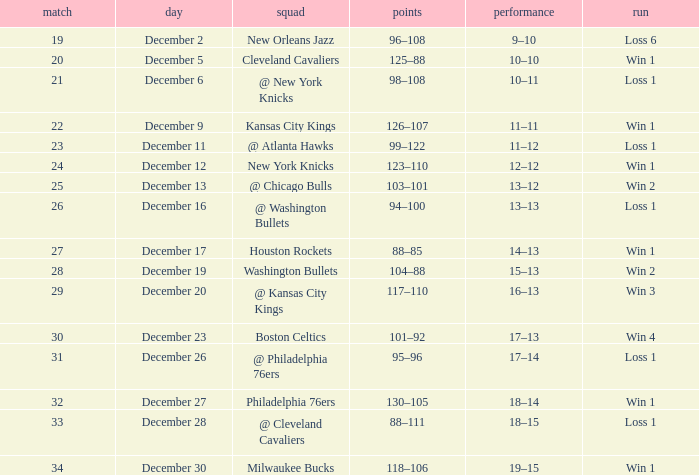What Game had a Score of 101–92? 30.0. 